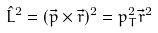Convert formula to latex. <formula><loc_0><loc_0><loc_500><loc_500>\hat { L } ^ { 2 } = ( \vec { p } \times \vec { r } ) ^ { 2 } = p ^ { 2 } _ { T } \vec { r } ^ { 2 }</formula> 